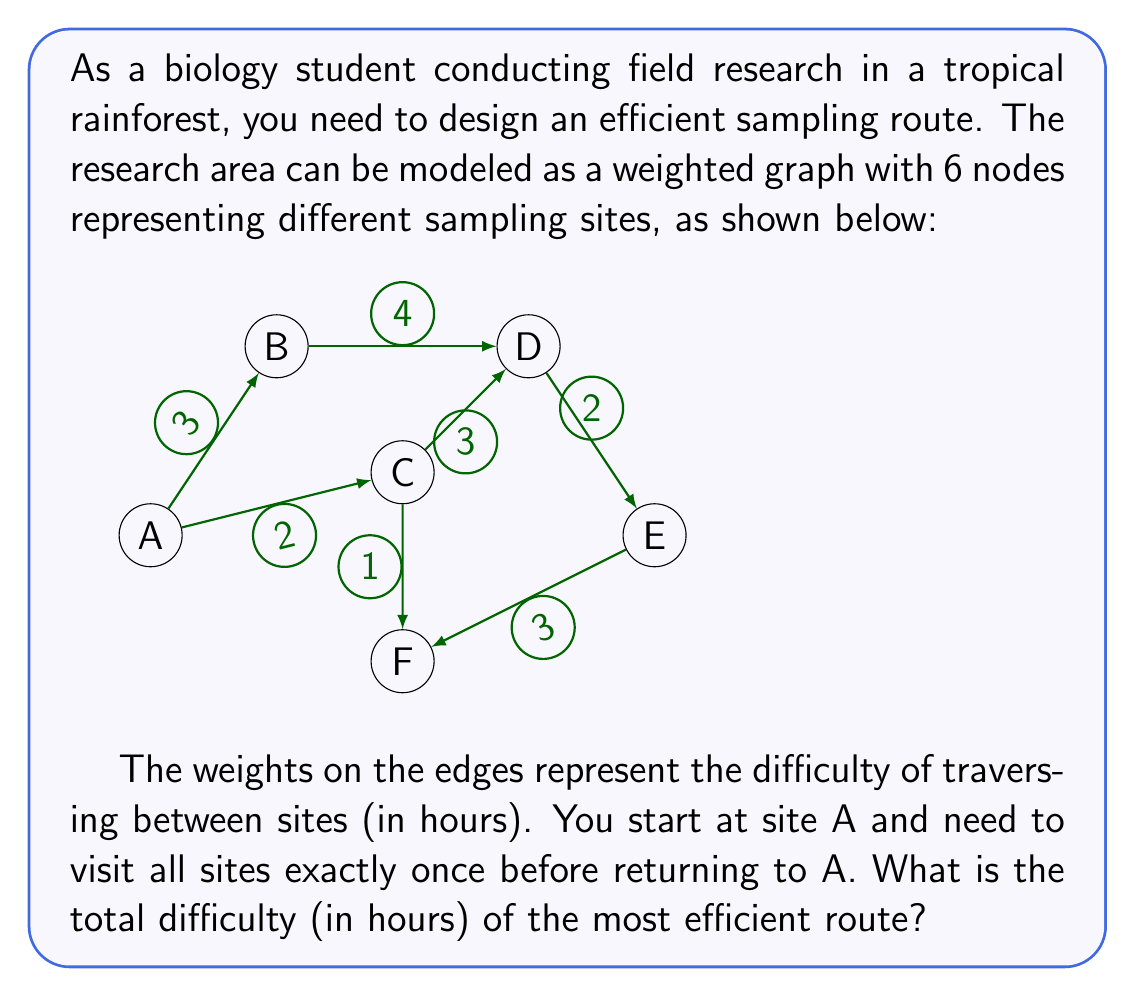Solve this math problem. To solve this problem, we need to find the Hamiltonian cycle with the lowest total weight in the given graph. This is known as the Traveling Salesman Problem (TSP).

Step 1: Identify all possible Hamiltonian cycles.
There are $(6-1)! = 5! = 120$ possible cycles, but due to the graph's structure, not all are valid.

Step 2: List valid Hamiltonian cycles:
1. A-B-D-E-F-C-A
2. A-B-D-C-F-E-A
3. A-C-D-E-F-B-A
4. A-C-F-E-D-B-A

Step 3: Calculate the total weight for each cycle:
1. A-B-D-E-F-C-A: $3 + 4 + 2 + 3 + 1 + 2 = 15$
2. A-B-D-C-F-E-A: $3 + 4 + 3 + 1 + 3 + 2 = 16$
3. A-C-D-E-F-B-A: $2 + 3 + 2 + 3 + 4 + 3 = 17$
4. A-C-F-E-D-B-A: $2 + 1 + 3 + 2 + 4 + 3 = 15$

Step 4: Identify the cycle(s) with the lowest total weight.
The cycles with the lowest total weight are 1 and 4, both with a total difficulty of 15 hours.

Therefore, the most efficient route has a total difficulty of 15 hours.
Answer: 15 hours 